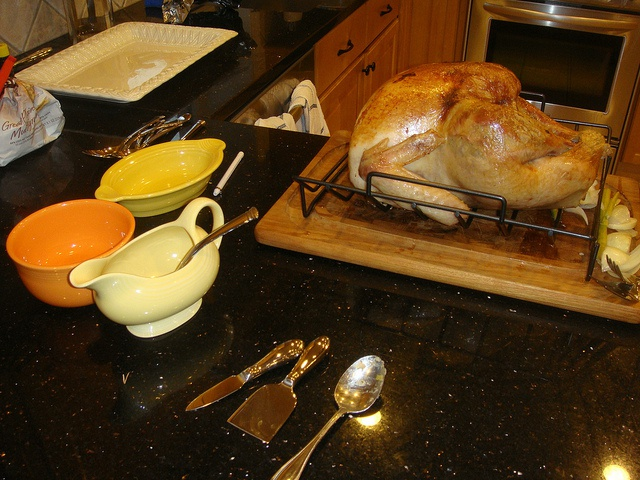Describe the objects in this image and their specific colors. I can see oven in brown, black, and maroon tones, bowl in brown, khaki, and tan tones, bowl in brown, orange, red, and maroon tones, bowl in brown, gold, and olive tones, and spoon in brown, olive, maroon, tan, and white tones in this image. 